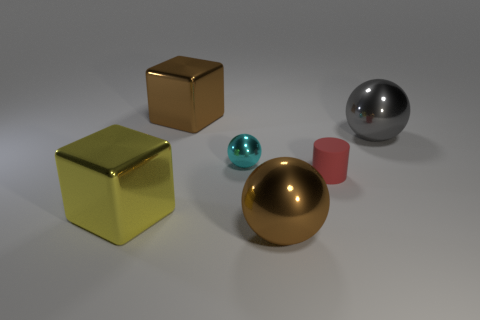There is a big thing that is behind the small red thing and on the left side of the brown metallic sphere; what color is it?
Ensure brevity in your answer.  Brown. The matte thing is what size?
Make the answer very short. Small. Do the block that is behind the tiny metallic thing and the tiny metal sphere have the same color?
Offer a terse response. No. Are there more red cylinders in front of the small sphere than spheres that are behind the big gray metal sphere?
Offer a very short reply. Yes. Is the number of yellow shiny objects greater than the number of small green spheres?
Make the answer very short. Yes. What size is the object that is both to the left of the cyan thing and behind the tiny red cylinder?
Provide a succinct answer. Large. What shape is the rubber thing?
Your response must be concise. Cylinder. Are there any other things that are the same size as the cyan metallic sphere?
Provide a succinct answer. Yes. Are there more small red rubber objects on the left side of the rubber cylinder than large metallic cubes?
Make the answer very short. No. There is a large thing that is to the left of the big brown shiny thing that is behind the small object on the right side of the large brown metallic ball; what is its shape?
Your answer should be very brief. Cube. 